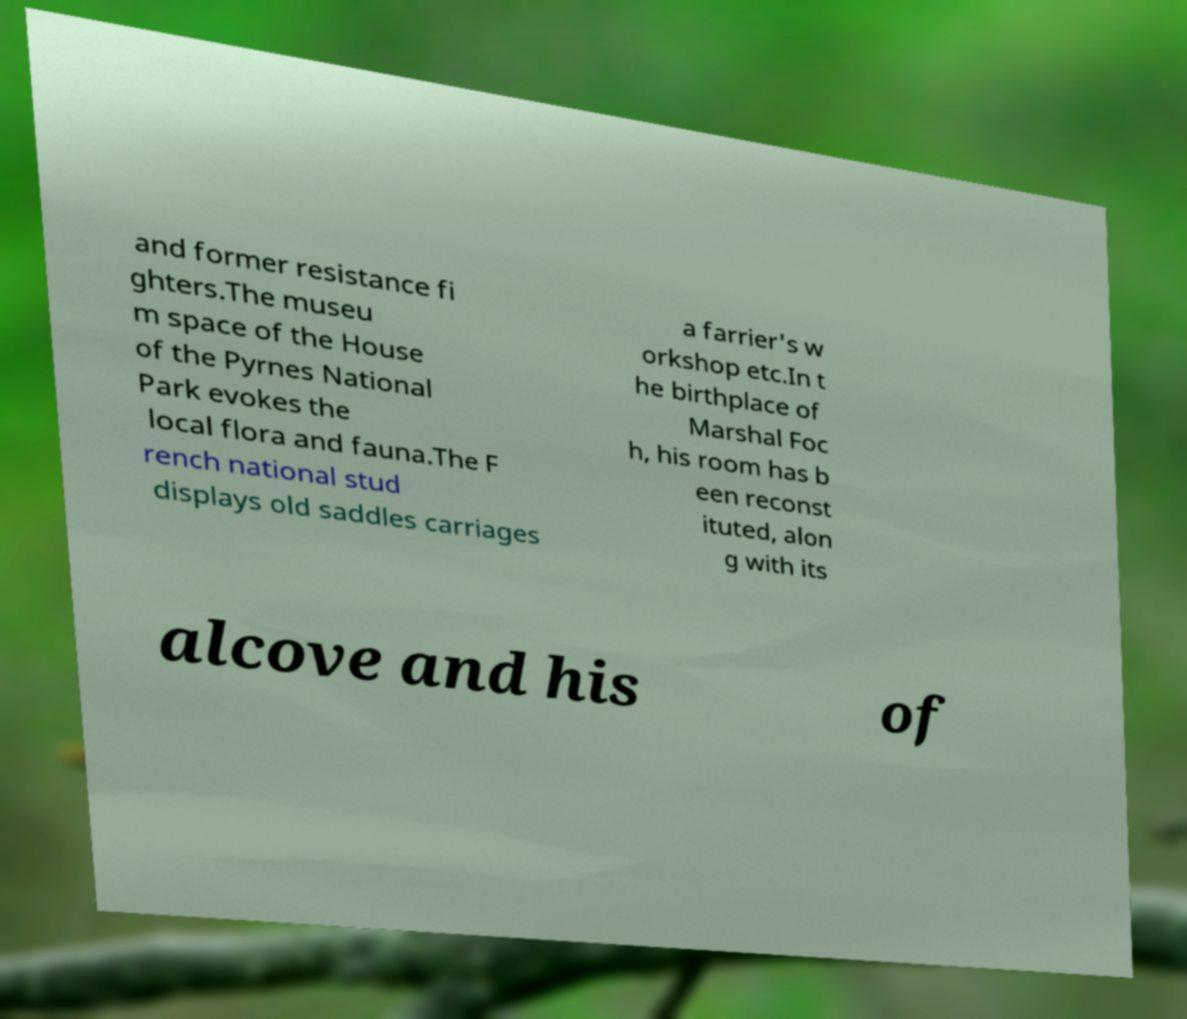Can you read and provide the text displayed in the image?This photo seems to have some interesting text. Can you extract and type it out for me? and former resistance fi ghters.The museu m space of the House of the Pyrnes National Park evokes the local flora and fauna.The F rench national stud displays old saddles carriages a farrier's w orkshop etc.In t he birthplace of Marshal Foc h, his room has b een reconst ituted, alon g with its alcove and his of 